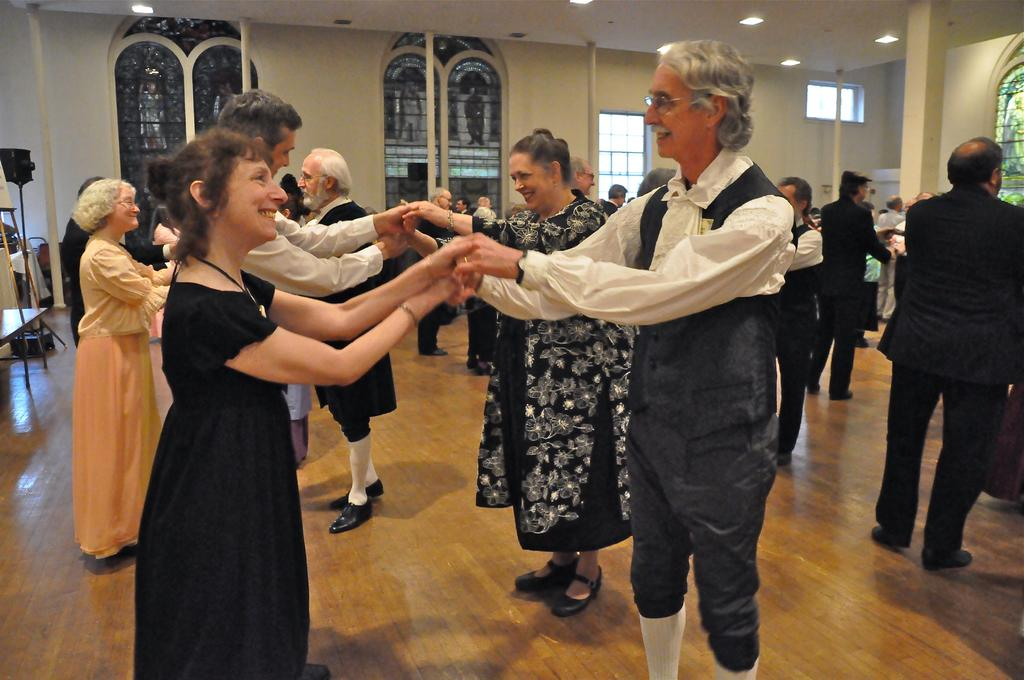How many people are in the image? There are people in the image, but the exact number is not specified. What are the people doing in the image? The people are holding hands and dancing in the image. What architectural feature can be seen in the image? Windows are visible in the image, and they are on the walls. Can you see a yak in the image? No, there is no yak present in the image. Is there a baby involved in the war depicted in the image? There is no war depicted in the image, and therefore no baby involved in it. 